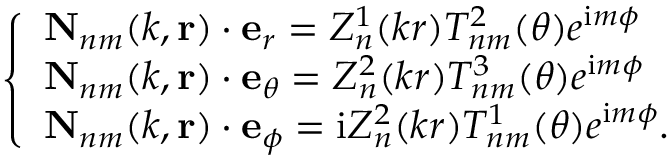Convert formula to latex. <formula><loc_0><loc_0><loc_500><loc_500>\left \{ \begin{array} { l l } { N _ { n m } ( k , r ) \cdot e _ { r } = Z _ { n } ^ { 1 } ( k r ) T _ { n m } ^ { 2 } ( \theta ) e ^ { i m \phi } } \\ { N _ { n m } ( k , r ) \cdot e _ { \theta } = Z _ { n } ^ { 2 } ( k r ) T _ { n m } ^ { 3 } ( \theta ) e ^ { i m \phi } } \\ { N _ { n m } ( k , r ) \cdot e _ { \phi } = i Z _ { n } ^ { 2 } ( k r ) T _ { n m } ^ { 1 } ( \theta ) e ^ { i m \phi } . } \end{array}</formula> 